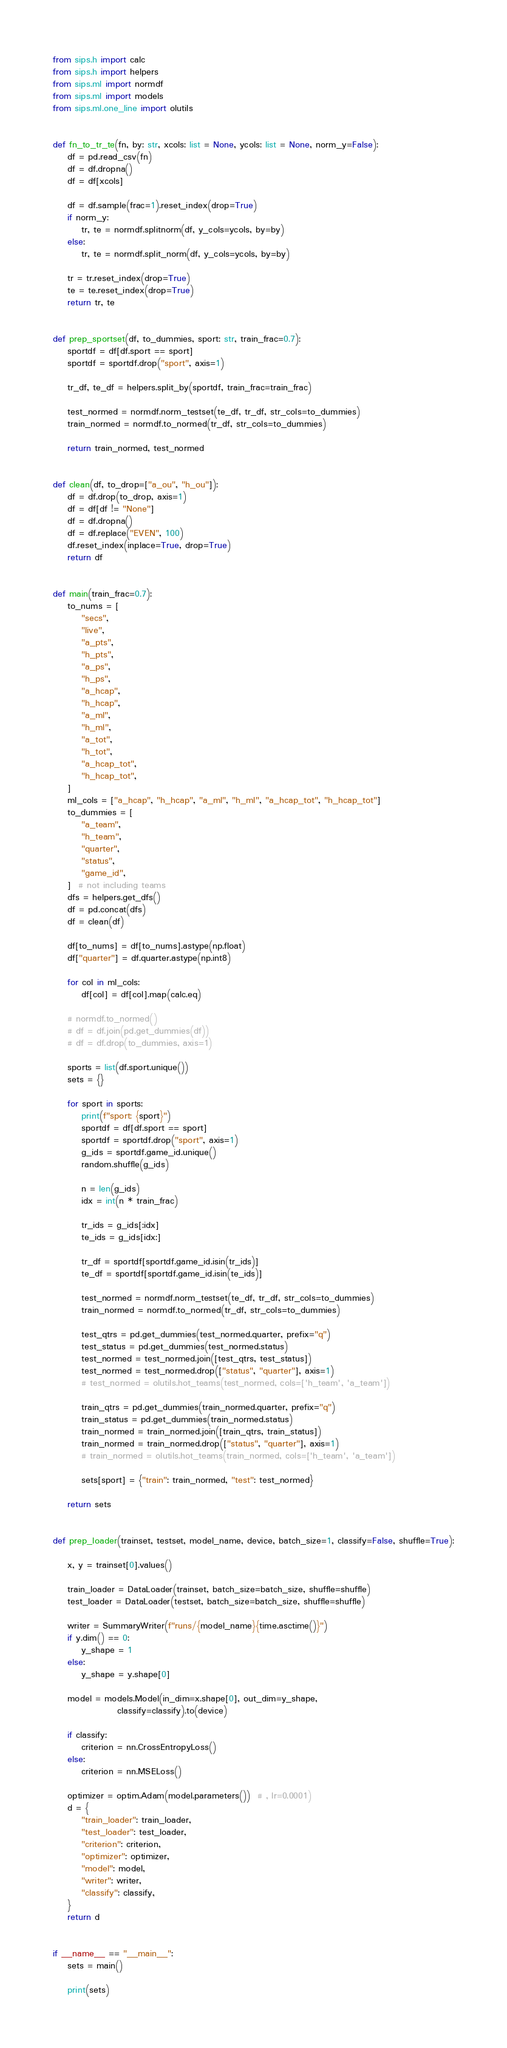<code> <loc_0><loc_0><loc_500><loc_500><_Python_>
from sips.h import calc
from sips.h import helpers
from sips.ml import normdf
from sips.ml import models
from sips.ml.one_line import olutils


def fn_to_tr_te(fn, by: str, xcols: list = None, ycols: list = None, norm_y=False):
    df = pd.read_csv(fn)
    df = df.dropna()
    df = df[xcols]

    df = df.sample(frac=1).reset_index(drop=True)
    if norm_y:
        tr, te = normdf.splitnorm(df, y_cols=ycols, by=by)
    else:
        tr, te = normdf.split_norm(df, y_cols=ycols, by=by)
    
    tr = tr.reset_index(drop=True)
    te = te.reset_index(drop=True)
    return tr, te


def prep_sportset(df, to_dummies, sport: str, train_frac=0.7):
    sportdf = df[df.sport == sport]
    sportdf = sportdf.drop("sport", axis=1)

    tr_df, te_df = helpers.split_by(sportdf, train_frac=train_frac)

    test_normed = normdf.norm_testset(te_df, tr_df, str_cols=to_dummies)
    train_normed = normdf.to_normed(tr_df, str_cols=to_dummies)

    return train_normed, test_normed


def clean(df, to_drop=["a_ou", "h_ou"]):
    df = df.drop(to_drop, axis=1)
    df = df[df != "None"]
    df = df.dropna()
    df = df.replace("EVEN", 100)
    df.reset_index(inplace=True, drop=True)
    return df


def main(train_frac=0.7):
    to_nums = [
        "secs",
        "live",
        "a_pts",
        "h_pts",
        "a_ps",
        "h_ps",
        "a_hcap",
        "h_hcap",
        "a_ml",
        "h_ml",
        "a_tot",
        "h_tot",
        "a_hcap_tot",
        "h_hcap_tot",
    ]
    ml_cols = ["a_hcap", "h_hcap", "a_ml", "h_ml", "a_hcap_tot", "h_hcap_tot"]
    to_dummies = [
        "a_team",
        "h_team",
        "quarter",
        "status",
        "game_id",
    ]  # not including teams
    dfs = helpers.get_dfs()
    df = pd.concat(dfs)
    df = clean(df)

    df[to_nums] = df[to_nums].astype(np.float)
    df["quarter"] = df.quarter.astype(np.int8)

    for col in ml_cols:
        df[col] = df[col].map(calc.eq)

    # normdf.to_normed()
    # df = df.join(pd.get_dummies(df))
    # df = df.drop(to_dummies, axis=1)

    sports = list(df.sport.unique())
    sets = {}

    for sport in sports:
        print(f"sport: {sport}")
        sportdf = df[df.sport == sport]
        sportdf = sportdf.drop("sport", axis=1)
        g_ids = sportdf.game_id.unique()
        random.shuffle(g_ids)

        n = len(g_ids)
        idx = int(n * train_frac)

        tr_ids = g_ids[:idx]
        te_ids = g_ids[idx:]

        tr_df = sportdf[sportdf.game_id.isin(tr_ids)]
        te_df = sportdf[sportdf.game_id.isin(te_ids)]

        test_normed = normdf.norm_testset(te_df, tr_df, str_cols=to_dummies)
        train_normed = normdf.to_normed(tr_df, str_cols=to_dummies)

        test_qtrs = pd.get_dummies(test_normed.quarter, prefix="q")
        test_status = pd.get_dummies(test_normed.status)
        test_normed = test_normed.join([test_qtrs, test_status])
        test_normed = test_normed.drop(["status", "quarter"], axis=1)
        # test_normed = olutils.hot_teams(test_normed, cols=['h_team', 'a_team'])

        train_qtrs = pd.get_dummies(train_normed.quarter, prefix="q")
        train_status = pd.get_dummies(train_normed.status)
        train_normed = train_normed.join([train_qtrs, train_status])
        train_normed = train_normed.drop(["status", "quarter"], axis=1)
        # train_normed = olutils.hot_teams(train_normed, cols=['h_team', 'a_team'])

        sets[sport] = {"train": train_normed, "test": test_normed}

    return sets


def prep_loader(trainset, testset, model_name, device, batch_size=1, classify=False, shuffle=True):

    x, y = trainset[0].values()

    train_loader = DataLoader(trainset, batch_size=batch_size, shuffle=shuffle)
    test_loader = DataLoader(testset, batch_size=batch_size, shuffle=shuffle)

    writer = SummaryWriter(f"runs/{model_name}{time.asctime()}")
    if y.dim() == 0:
        y_shape = 1
    else:
        y_shape = y.shape[0]

    model = models.Model(in_dim=x.shape[0], out_dim=y_shape,
                  classify=classify).to(device)

    if classify:
        criterion = nn.CrossEntropyLoss()
    else:
        criterion = nn.MSELoss()

    optimizer = optim.Adam(model.parameters())  # , lr=0.0001)
    d = {
        "train_loader": train_loader,
        "test_loader": test_loader,
        "criterion": criterion,
        "optimizer": optimizer,
        "model": model,
        "writer": writer,
        "classify": classify,
    }
    return d


if __name__ == "__main__":
    sets = main()

    print(sets)
</code> 